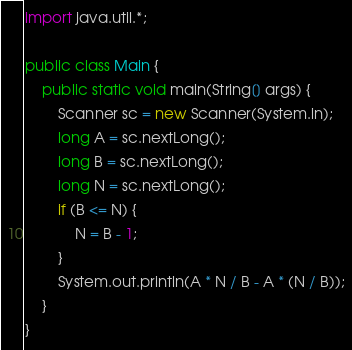Convert code to text. <code><loc_0><loc_0><loc_500><loc_500><_Java_>import java.util.*;
 
public class Main {
    public static void main(String[] args) {
        Scanner sc = new Scanner(System.in);
        long A = sc.nextLong();
        long B = sc.nextLong();
        long N = sc.nextLong();
        if (B <= N) {
        	N = B - 1;
        }
        System.out.println(A * N / B - A * (N / B));
    }
}</code> 